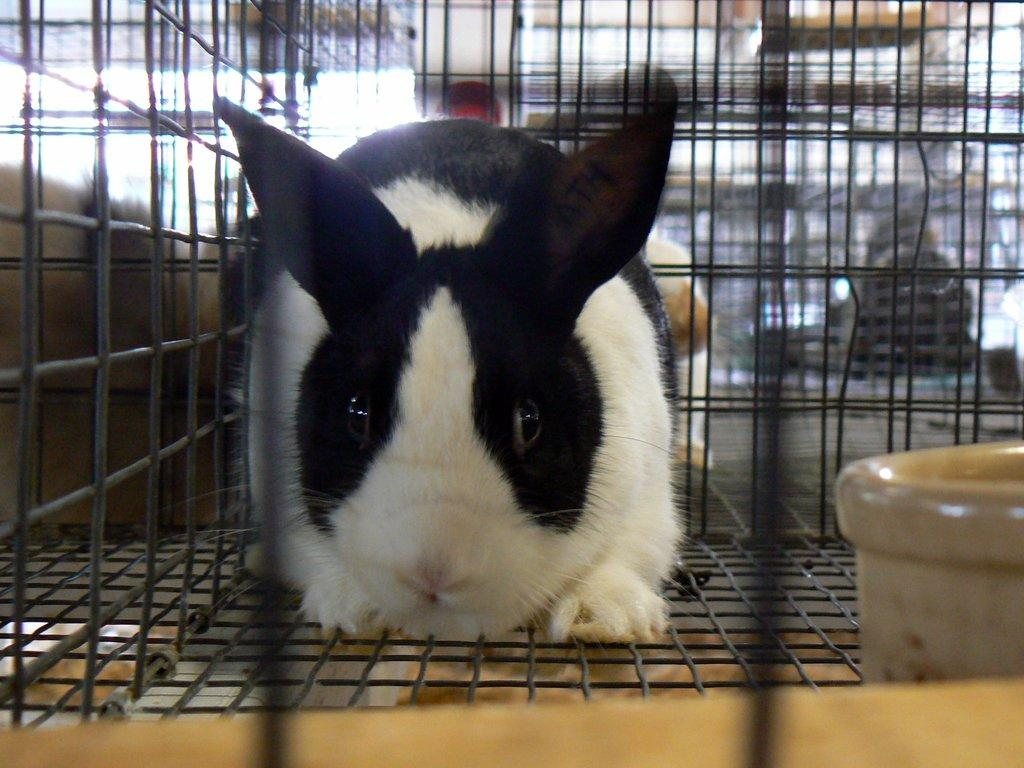What type of animal is in the image? There is a rabbit in the image. Where is the rabbit located? The rabbit is in a cage. What can be seen beside the rabbit in the image? There is an object beside the rabbit in the image. What type of curtain can be seen hanging in the image? There is no curtain present in the image. Can you tell me how many spoons are visible in the image? There is no spoon present in the image. 